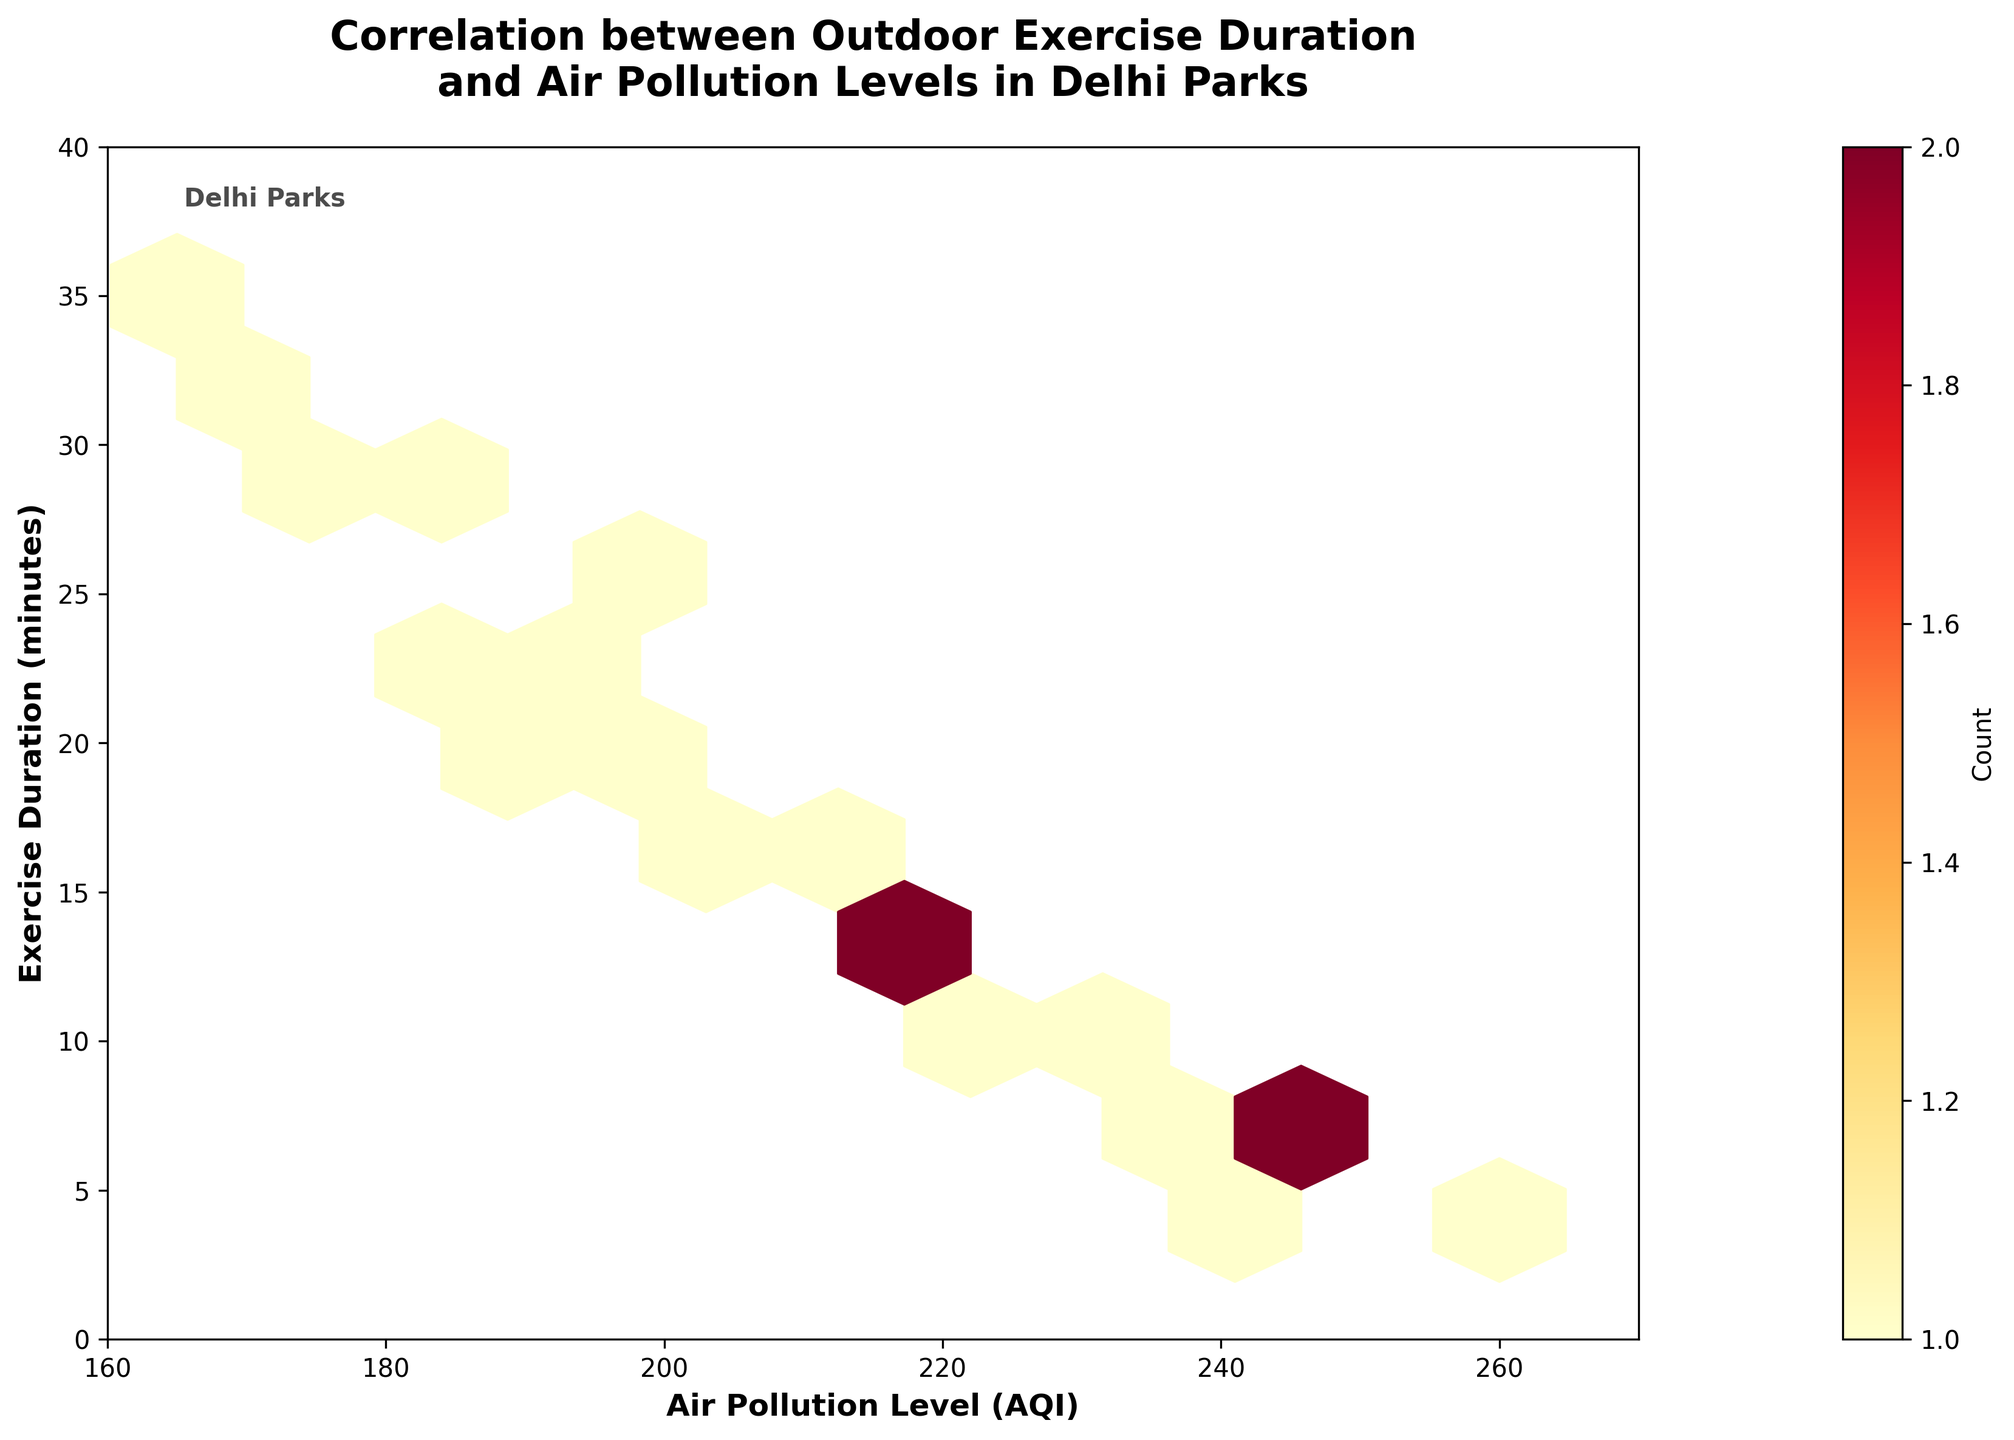What are the x-axis and y-axis labels in the plot? The x-axis label is "Air Pollution Level (AQI)" and the y-axis label is "Exercise Duration (minutes)". These labels are located along the bottom and left sides of the plot respectively.
Answer: Air Pollution Level (AQI), Exercise Duration (minutes) What is the title of the plot? The title of the plot is "Correlation between Outdoor Exercise Duration and Air Pollution Levels in Delhi Parks" and it is displayed at the top center of the plot.
Answer: Correlation between Outdoor Exercise Duration and Air Pollution Levels in Delhi Parks Which hexbin color represents the highest count of points? In the hexbin plot, the color representing the highest count of points is the darkest hue of the color map used, which is a deep red according to the 'YlOrRd' color scheme.
Answer: Deep red How does the exercise duration change as air pollution levels increase? By examining the distribution of the hexbins, we can see that higher air pollution levels (AQI > 230) tend to have lower exercise durations (usually below 15 minutes). This indicates that as air pollution increases, people tend to exercise less.
Answer: Exercise duration decreases What is the relationship between air pollution level and exercise duration according to the plot? The overall trend from the plot indicates a negative correlation; as the air pollution level increases, the exercise duration seems to decrease. This is evident from the clustering of points towards the lower duration for higher AQIs.
Answer: Negative correlation From the plot, which air pollution level range has the most data points with exercise duration around 20 minutes? The range of air pollution levels with the most data points around 20 minutes of exercise duration is approximately between 180 and 200 AQI. This can be interpreted from the denser concentration of hexagons in this range.
Answer: 180-200 AQI Approximately how many parks have AQI levels of 220 or higher? By counting the individual hexbins where AQI levels are 220 or higher, there appear to be around six parks falling in this category.
Answer: Six parks What does the color bar next to the plot indicate? The color bar next to the plot indicates the count of data points (parks) within each hexbin. The color ranges from light yellow (low count) to dark red (high count).
Answer: Count of data points Which park has the highest air pollution level and what is its exercise duration? By referring to the data provided and recognizing that the highest AQI level is 260 (Yamuna Biodiversity Park), we can see that its exercise duration is 4 minutes.
Answer: Yamuna Biodiversity Park, 4 minutes 